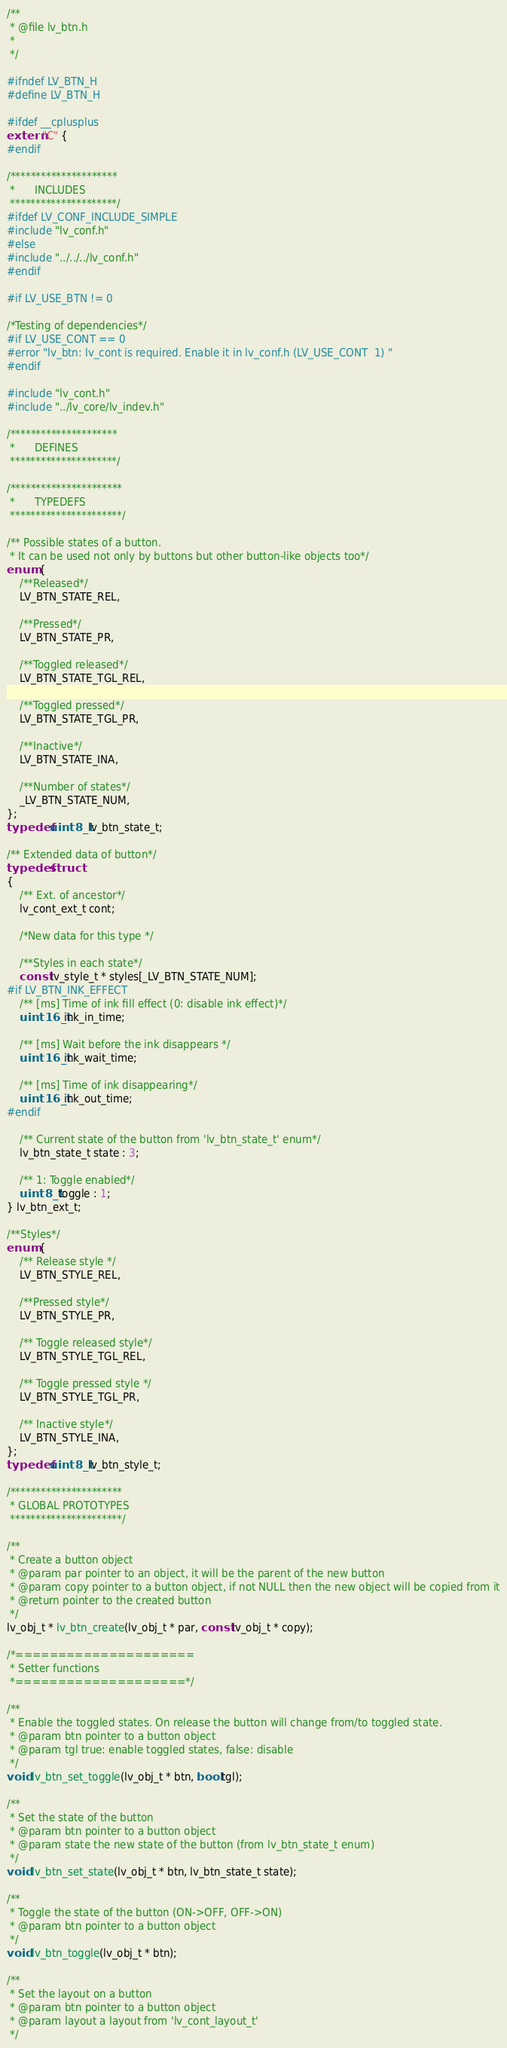<code> <loc_0><loc_0><loc_500><loc_500><_C_>/**
 * @file lv_btn.h
 *
 */

#ifndef LV_BTN_H
#define LV_BTN_H

#ifdef __cplusplus
extern "C" {
#endif

/*********************
 *      INCLUDES
 *********************/
#ifdef LV_CONF_INCLUDE_SIMPLE
#include "lv_conf.h"
#else
#include "../../../lv_conf.h"
#endif

#if LV_USE_BTN != 0

/*Testing of dependencies*/
#if LV_USE_CONT == 0
#error "lv_btn: lv_cont is required. Enable it in lv_conf.h (LV_USE_CONT  1) "
#endif

#include "lv_cont.h"
#include "../lv_core/lv_indev.h"

/*********************
 *      DEFINES
 *********************/

/**********************
 *      TYPEDEFS
 **********************/

/** Possible states of a button.
 * It can be used not only by buttons but other button-like objects too*/
enum {
    /**Released*/
    LV_BTN_STATE_REL,

    /**Pressed*/
    LV_BTN_STATE_PR,

    /**Toggled released*/
    LV_BTN_STATE_TGL_REL,

    /**Toggled pressed*/
    LV_BTN_STATE_TGL_PR,

    /**Inactive*/
    LV_BTN_STATE_INA,

    /**Number of states*/
    _LV_BTN_STATE_NUM,
};
typedef uint8_t lv_btn_state_t;

/** Extended data of button*/
typedef struct
{
    /** Ext. of ancestor*/
    lv_cont_ext_t cont;

    /*New data for this type */

    /**Styles in each state*/
    const lv_style_t * styles[_LV_BTN_STATE_NUM];
#if LV_BTN_INK_EFFECT
    /** [ms] Time of ink fill effect (0: disable ink effect)*/
    uint16_t ink_in_time;

    /** [ms] Wait before the ink disappears */
    uint16_t ink_wait_time;

    /** [ms] Time of ink disappearing*/
    uint16_t ink_out_time;
#endif

    /** Current state of the button from 'lv_btn_state_t' enum*/
    lv_btn_state_t state : 3;

    /** 1: Toggle enabled*/
    uint8_t toggle : 1;
} lv_btn_ext_t;

/**Styles*/
enum {
    /** Release style */
    LV_BTN_STYLE_REL,

    /**Pressed style*/
    LV_BTN_STYLE_PR,

    /** Toggle released style*/
    LV_BTN_STYLE_TGL_REL,

    /** Toggle pressed style */
    LV_BTN_STYLE_TGL_PR,

    /** Inactive style*/
    LV_BTN_STYLE_INA,
};
typedef uint8_t lv_btn_style_t;

/**********************
 * GLOBAL PROTOTYPES
 **********************/

/**
 * Create a button object
 * @param par pointer to an object, it will be the parent of the new button
 * @param copy pointer to a button object, if not NULL then the new object will be copied from it
 * @return pointer to the created button
 */
lv_obj_t * lv_btn_create(lv_obj_t * par, const lv_obj_t * copy);

/*=====================
 * Setter functions
 *====================*/

/**
 * Enable the toggled states. On release the button will change from/to toggled state.
 * @param btn pointer to a button object
 * @param tgl true: enable toggled states, false: disable
 */
void lv_btn_set_toggle(lv_obj_t * btn, bool tgl);

/**
 * Set the state of the button
 * @param btn pointer to a button object
 * @param state the new state of the button (from lv_btn_state_t enum)
 */
void lv_btn_set_state(lv_obj_t * btn, lv_btn_state_t state);

/**
 * Toggle the state of the button (ON->OFF, OFF->ON)
 * @param btn pointer to a button object
 */
void lv_btn_toggle(lv_obj_t * btn);

/**
 * Set the layout on a button
 * @param btn pointer to a button object
 * @param layout a layout from 'lv_cont_layout_t'
 */</code> 